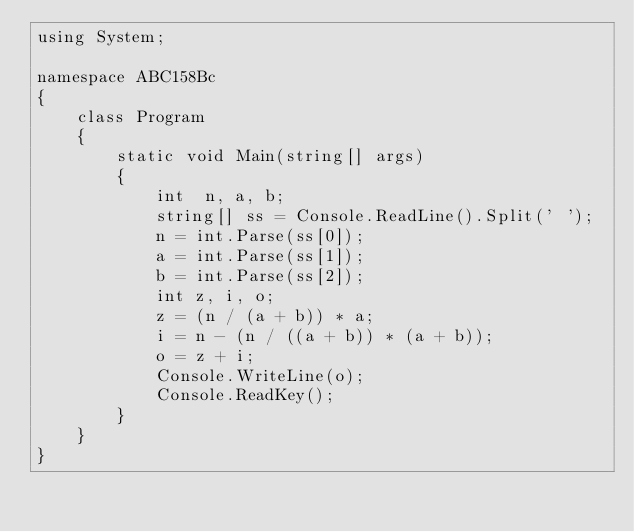<code> <loc_0><loc_0><loc_500><loc_500><_C#_>using System;

namespace ABC158Bc
{
    class Program
    {
        static void Main(string[] args)
        {
            int  n, a, b;
            string[] ss = Console.ReadLine().Split(' ');
            n = int.Parse(ss[0]);
            a = int.Parse(ss[1]);
            b = int.Parse(ss[2]);
            int z, i, o;
            z = (n / (a + b)) * a;
            i = n - (n / ((a + b)) * (a + b));
            o = z + i;
            Console.WriteLine(o);
            Console.ReadKey();
        }
    }
}</code> 